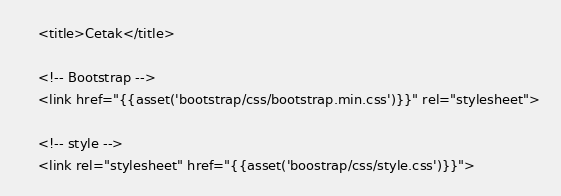Convert code to text. <code><loc_0><loc_0><loc_500><loc_500><_PHP_>    <title>Cetak</title>

    <!-- Bootstrap -->
    <link href="{{asset('bootstrap/css/bootstrap.min.css')}}" rel="stylesheet">
    
    <!-- style -->
    <link rel="stylesheet" href="{{asset('boostrap/css/style.css')}}"></code> 